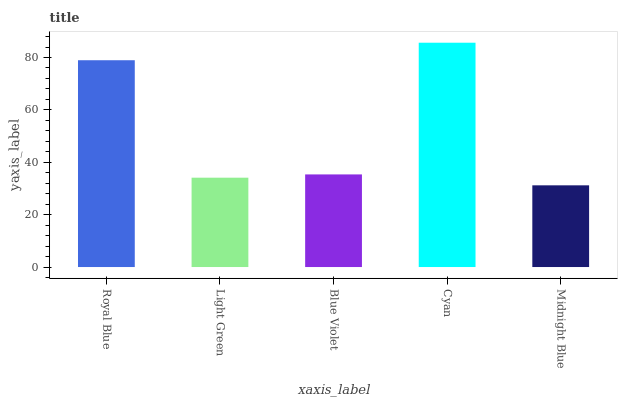Is Midnight Blue the minimum?
Answer yes or no. Yes. Is Cyan the maximum?
Answer yes or no. Yes. Is Light Green the minimum?
Answer yes or no. No. Is Light Green the maximum?
Answer yes or no. No. Is Royal Blue greater than Light Green?
Answer yes or no. Yes. Is Light Green less than Royal Blue?
Answer yes or no. Yes. Is Light Green greater than Royal Blue?
Answer yes or no. No. Is Royal Blue less than Light Green?
Answer yes or no. No. Is Blue Violet the high median?
Answer yes or no. Yes. Is Blue Violet the low median?
Answer yes or no. Yes. Is Cyan the high median?
Answer yes or no. No. Is Midnight Blue the low median?
Answer yes or no. No. 